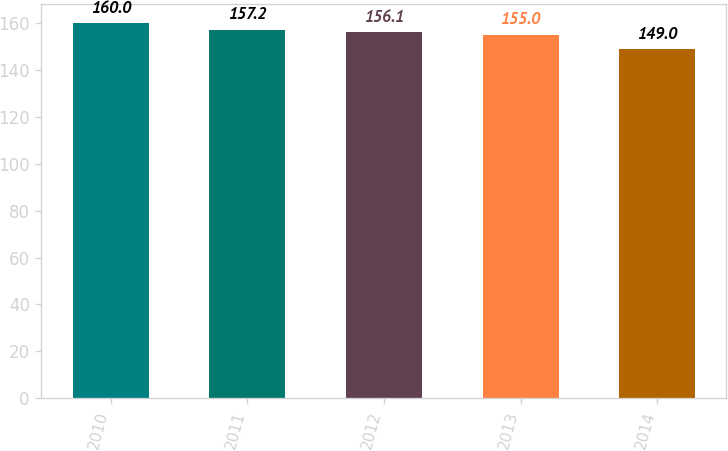Convert chart to OTSL. <chart><loc_0><loc_0><loc_500><loc_500><bar_chart><fcel>2010<fcel>2011<fcel>2012<fcel>2013<fcel>2014<nl><fcel>160<fcel>157.2<fcel>156.1<fcel>155<fcel>149<nl></chart> 